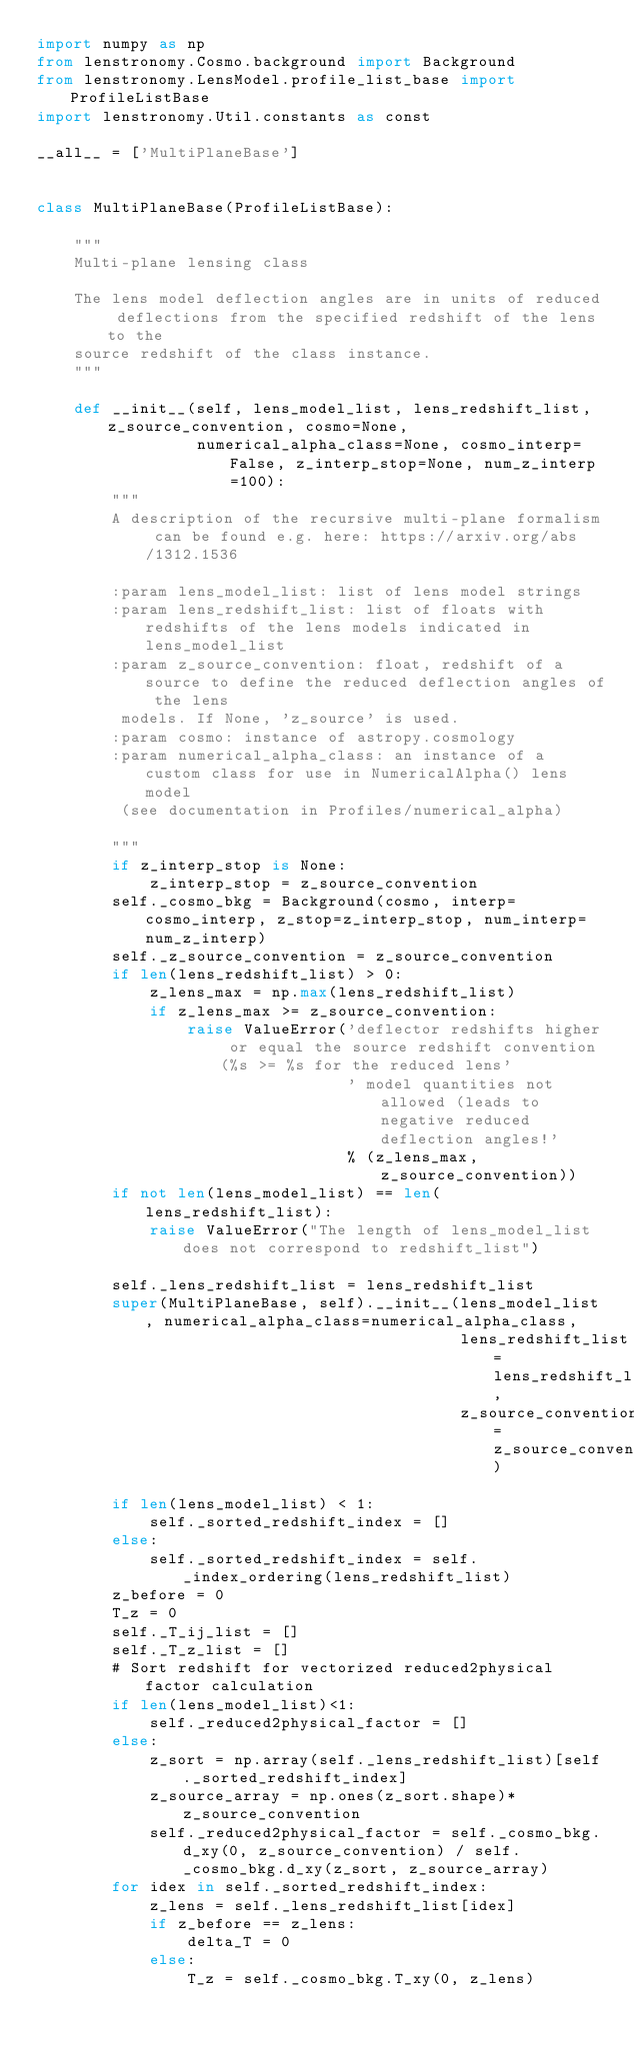Convert code to text. <code><loc_0><loc_0><loc_500><loc_500><_Python_>import numpy as np
from lenstronomy.Cosmo.background import Background
from lenstronomy.LensModel.profile_list_base import ProfileListBase
import lenstronomy.Util.constants as const

__all__ = ['MultiPlaneBase']


class MultiPlaneBase(ProfileListBase):

    """
    Multi-plane lensing class

    The lens model deflection angles are in units of reduced deflections from the specified redshift of the lens to the
    source redshift of the class instance.
    """

    def __init__(self, lens_model_list, lens_redshift_list, z_source_convention, cosmo=None,
                 numerical_alpha_class=None, cosmo_interp=False, z_interp_stop=None, num_z_interp=100):
        """
        A description of the recursive multi-plane formalism can be found e.g. here: https://arxiv.org/abs/1312.1536

        :param lens_model_list: list of lens model strings
        :param lens_redshift_list: list of floats with redshifts of the lens models indicated in lens_model_list
        :param z_source_convention: float, redshift of a source to define the reduced deflection angles of the lens
         models. If None, 'z_source' is used.
        :param cosmo: instance of astropy.cosmology
        :param numerical_alpha_class: an instance of a custom class for use in NumericalAlpha() lens model
         (see documentation in Profiles/numerical_alpha)

        """
        if z_interp_stop is None:
            z_interp_stop = z_source_convention
        self._cosmo_bkg = Background(cosmo, interp=cosmo_interp, z_stop=z_interp_stop, num_interp=num_z_interp)
        self._z_source_convention = z_source_convention
        if len(lens_redshift_list) > 0:
            z_lens_max = np.max(lens_redshift_list)
            if z_lens_max >= z_source_convention:
                raise ValueError('deflector redshifts higher or equal the source redshift convention (%s >= %s for the reduced lens'
                                 ' model quantities not allowed (leads to negative reduced deflection angles!'
                                 % (z_lens_max, z_source_convention))
        if not len(lens_model_list) == len(lens_redshift_list):
            raise ValueError("The length of lens_model_list does not correspond to redshift_list")

        self._lens_redshift_list = lens_redshift_list
        super(MultiPlaneBase, self).__init__(lens_model_list, numerical_alpha_class=numerical_alpha_class,
                                             lens_redshift_list=lens_redshift_list,
                                             z_source_convention=z_source_convention)

        if len(lens_model_list) < 1:
            self._sorted_redshift_index = []
        else:
            self._sorted_redshift_index = self._index_ordering(lens_redshift_list)
        z_before = 0
        T_z = 0
        self._T_ij_list = []
        self._T_z_list = []
        # Sort redshift for vectorized reduced2physical factor calculation
        if len(lens_model_list)<1:
            self._reduced2physical_factor = []
        else:
            z_sort = np.array(self._lens_redshift_list)[self._sorted_redshift_index]
            z_source_array = np.ones(z_sort.shape)*z_source_convention
            self._reduced2physical_factor = self._cosmo_bkg.d_xy(0, z_source_convention) / self._cosmo_bkg.d_xy(z_sort, z_source_array)
        for idex in self._sorted_redshift_index:
            z_lens = self._lens_redshift_list[idex]
            if z_before == z_lens:
                delta_T = 0
            else:
                T_z = self._cosmo_bkg.T_xy(0, z_lens)</code> 